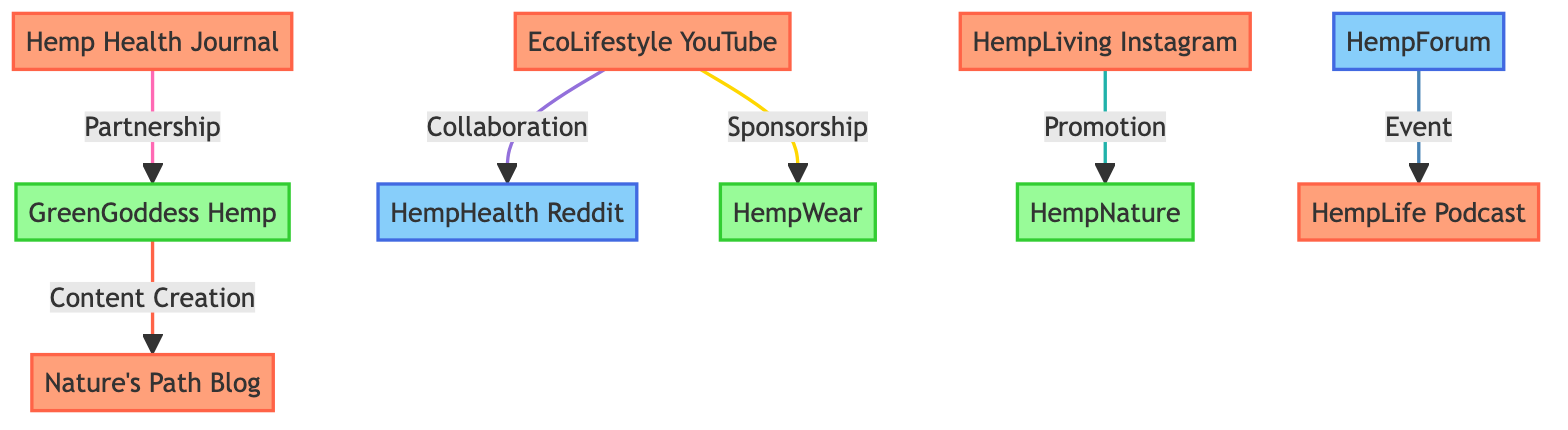What's the total number of nodes in the diagram? The diagram lists ten distinct entities related to hemp-based lifestyle influencing, including influencers, brands, and communities. Counting each one gives us a total of 10 nodes.
Answer: 10 Which influencer is partnered with GreenGoddess Hemp? According to the diagram, Hemp Health Journal is directly linked to GreenGoddess Hemp through a partnership. This link indicates a close relationship between these two entities.
Answer: Hemp Health Journal What kind of relationship does EcoLifestyle YouTube Channel have with HempHealth Reddit Community? The diagram specifies a collaboration relationship between EcoLifestyle YouTube Channel and HempHealth Reddit Community. This means they work together, particularly for Q&A sessions.
Answer: Collaboration How many brands are featured in the diagram? There are three distinct brands listed in the diagram: GreenGoddess Hemp, HempWear, and HempNature. Counting these brands gives us a total of 3.
Answer: 3 Which influencer promotes products from HempNature? The diagram shows that HempLiving Instagram has a promotional link with HempNature, indicating their endorsement or advertisement of HempNature products.
Answer: HempLiving Instagram Is there any relationship type that connects brands with influencers? Yes, there are different types of relationships that connect brands with influencers, such as sponsorship, partnership, and content creation. The diagram highlights multiple interactions of this nature.
Answer: Yes Which community is associated with live events hosted by HempLife Podcast? According to the diagram, HempForum is the community that features live events hosted by HempLife Podcast, indicating its role as an interactive platform for discussing hemp-related topics.
Answer: HempForum Does the EcoLifestyle YouTube Channel have a sponsorship connection with any brand? Yes, EcoLifestyle YouTube Channel is sponsored by HempWear, as indicated in the diagram. This relationship shows that HempWear financially supports the channel in exchange for promotion.
Answer: Yes What is the type of content collaboration between GreenGoddess Hemp and Nature's Path Blog? The diagram indicates a content creation relationship between GreenGoddess Hemp and Nature's Path Blog, showing they cooperate to produce content related to hemp recipes.
Answer: Content Creation 